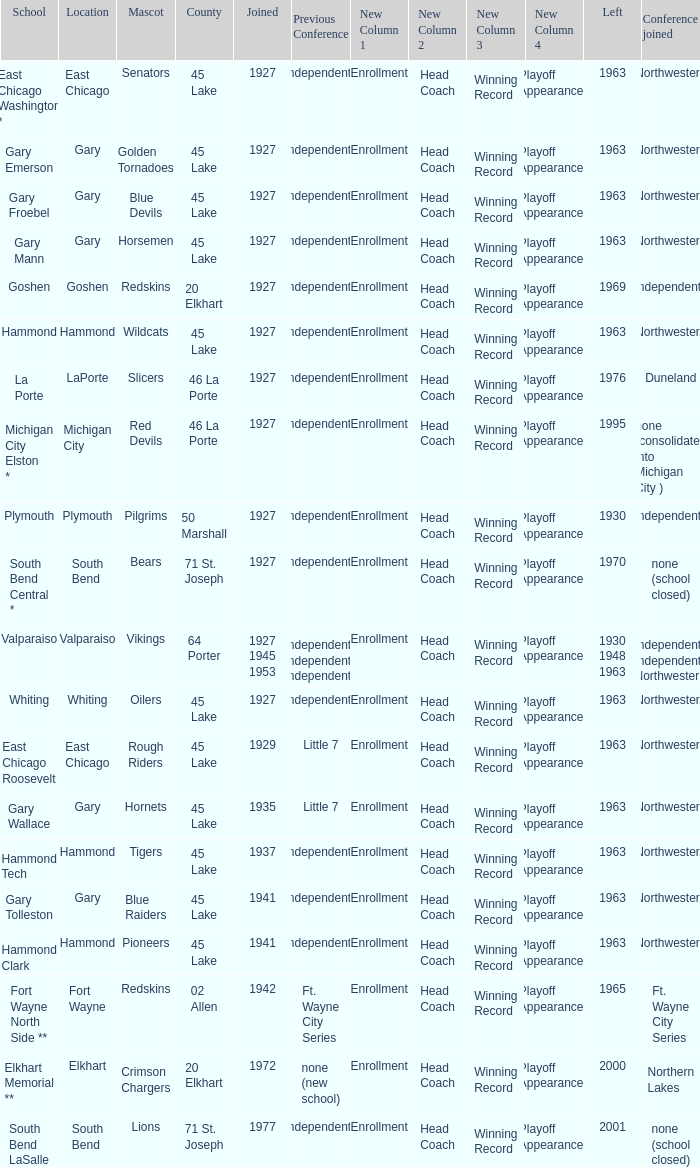Which conference held at School of whiting? Independents. 